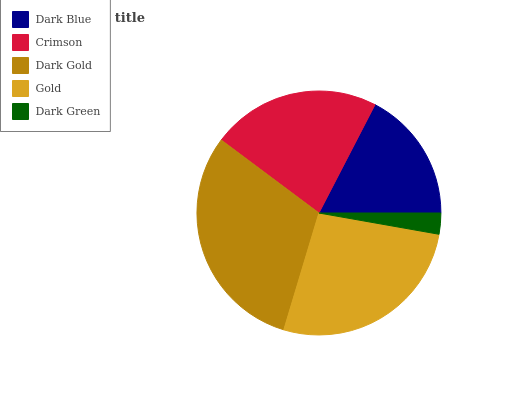Is Dark Green the minimum?
Answer yes or no. Yes. Is Dark Gold the maximum?
Answer yes or no. Yes. Is Crimson the minimum?
Answer yes or no. No. Is Crimson the maximum?
Answer yes or no. No. Is Crimson greater than Dark Blue?
Answer yes or no. Yes. Is Dark Blue less than Crimson?
Answer yes or no. Yes. Is Dark Blue greater than Crimson?
Answer yes or no. No. Is Crimson less than Dark Blue?
Answer yes or no. No. Is Crimson the high median?
Answer yes or no. Yes. Is Crimson the low median?
Answer yes or no. Yes. Is Dark Blue the high median?
Answer yes or no. No. Is Dark Gold the low median?
Answer yes or no. No. 